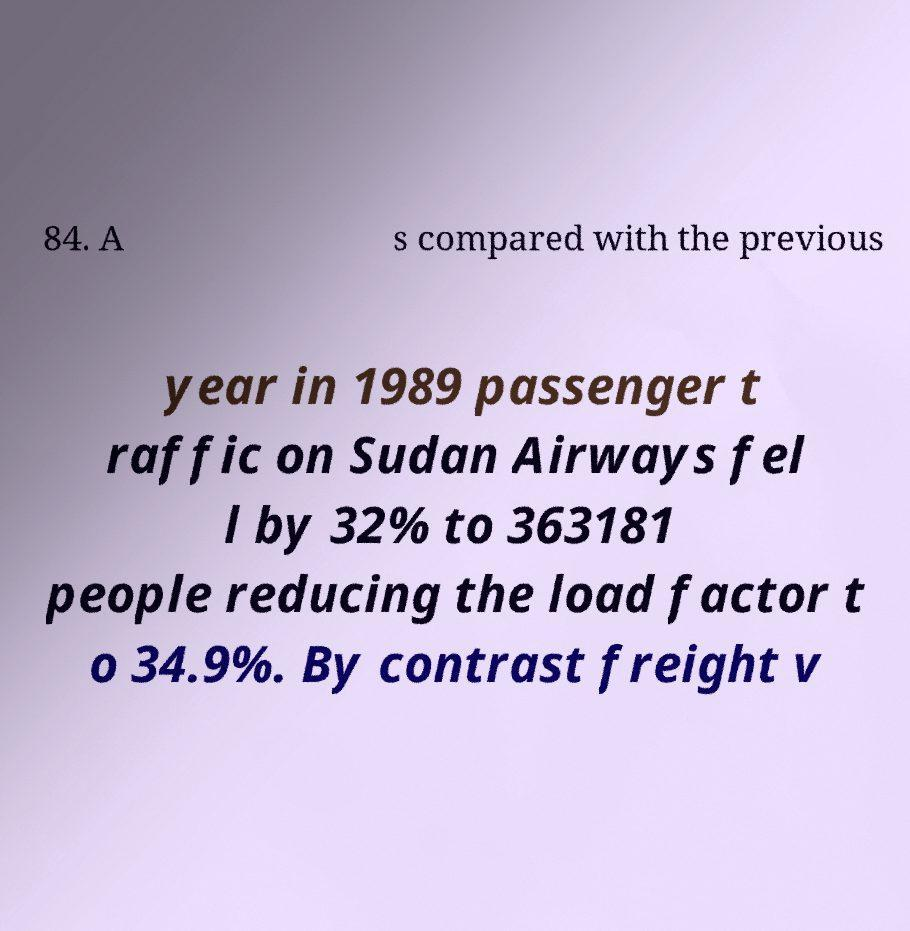Could you extract and type out the text from this image? 84. A s compared with the previous year in 1989 passenger t raffic on Sudan Airways fel l by 32% to 363181 people reducing the load factor t o 34.9%. By contrast freight v 